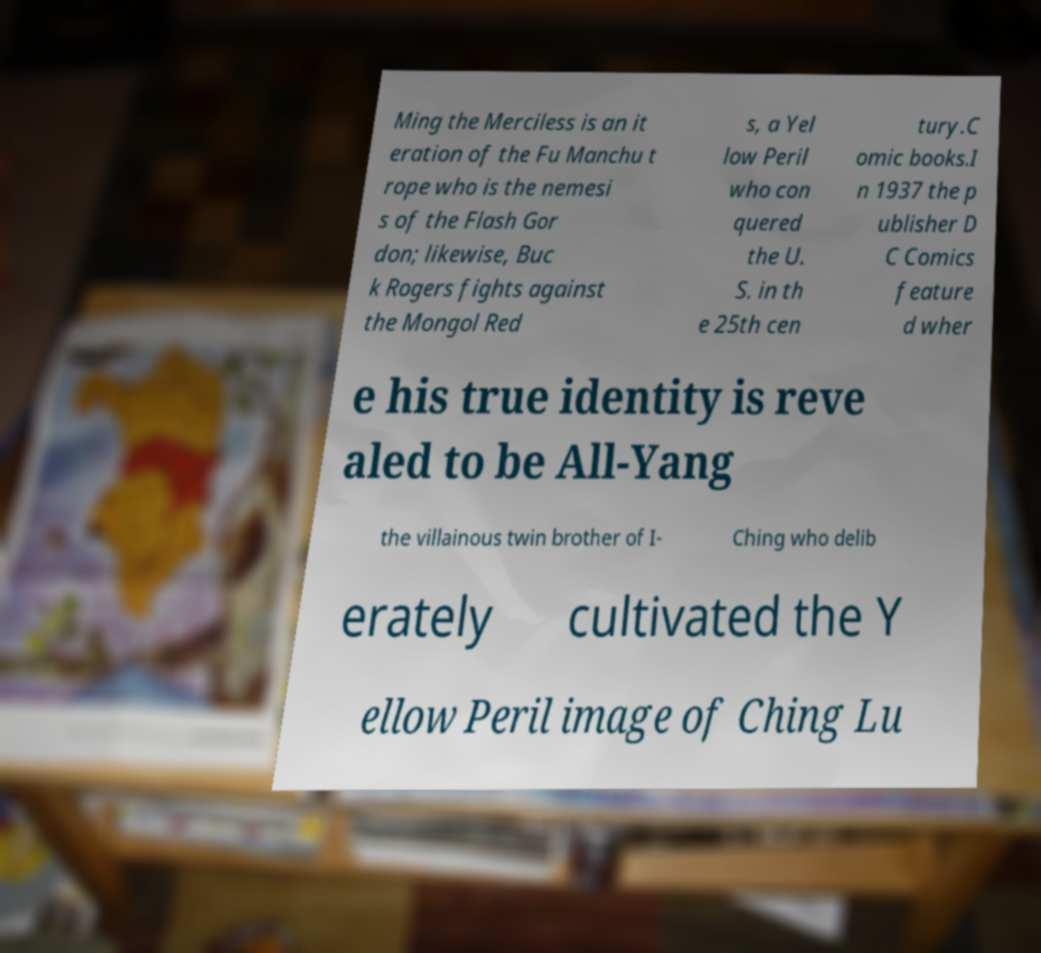Can you accurately transcribe the text from the provided image for me? Ming the Merciless is an it eration of the Fu Manchu t rope who is the nemesi s of the Flash Gor don; likewise, Buc k Rogers fights against the Mongol Red s, a Yel low Peril who con quered the U. S. in th e 25th cen tury.C omic books.I n 1937 the p ublisher D C Comics feature d wher e his true identity is reve aled to be All-Yang the villainous twin brother of I- Ching who delib erately cultivated the Y ellow Peril image of Ching Lu 